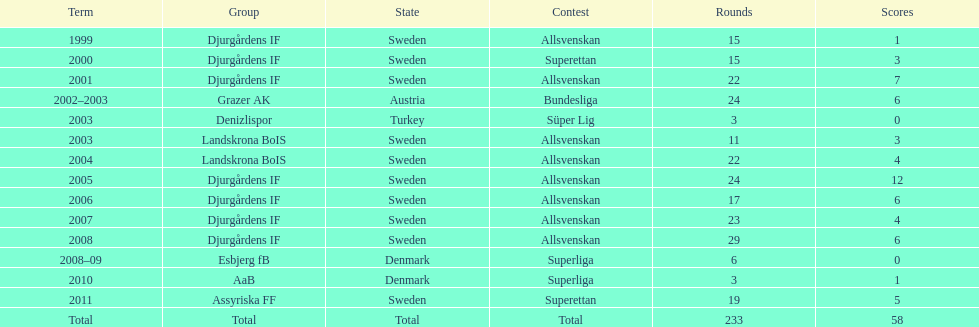What is the total number of matches? 233. 